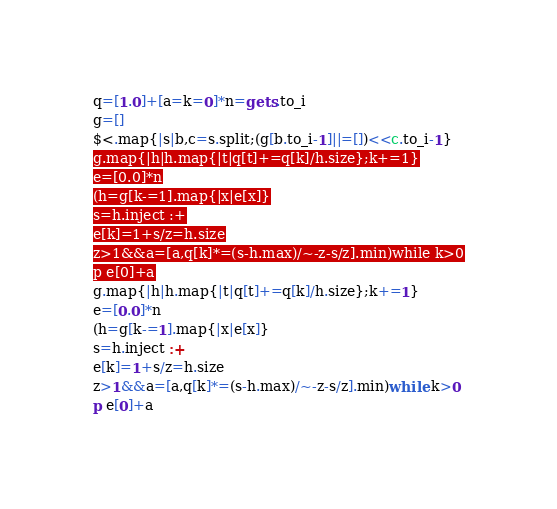Convert code to text. <code><loc_0><loc_0><loc_500><loc_500><_Ruby_>q=[1.0]+[a=k=0]*n=gets.to_i
g=[]
$<.map{|s|b,c=s.split;(g[b.to_i-1]||=[])<<c.to_i-1}
g.map{|h|h.map{|t|q[t]+=q[k]/h.size};k+=1}
e=[0.0]*n
(h=g[k-=1].map{|x|e[x]}
s=h.inject :+
e[k]=1+s/z=h.size
z>1&&a=[a,q[k]*=(s-h.max)/~-z-s/z].min)while k>0
p e[0]+a</code> 